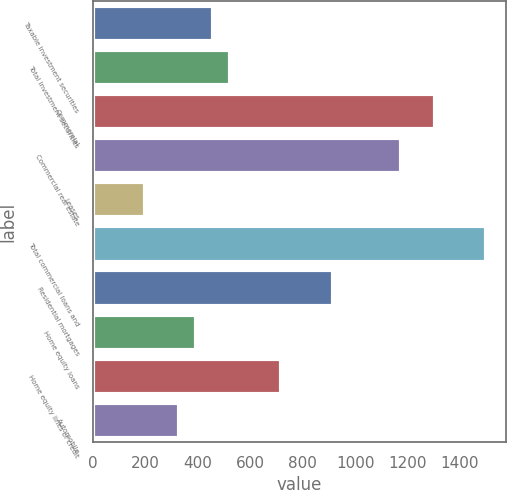<chart> <loc_0><loc_0><loc_500><loc_500><bar_chart><fcel>Taxable investment securities<fcel>Total investment securities<fcel>Commercial<fcel>Commercial real estate<fcel>Leases<fcel>Total commercial loans and<fcel>Residential mortgages<fcel>Home equity loans<fcel>Home equity lines of credit<fcel>Automobile<nl><fcel>458.7<fcel>523.8<fcel>1305<fcel>1174.8<fcel>198.3<fcel>1500.3<fcel>914.4<fcel>393.6<fcel>719.1<fcel>328.5<nl></chart> 